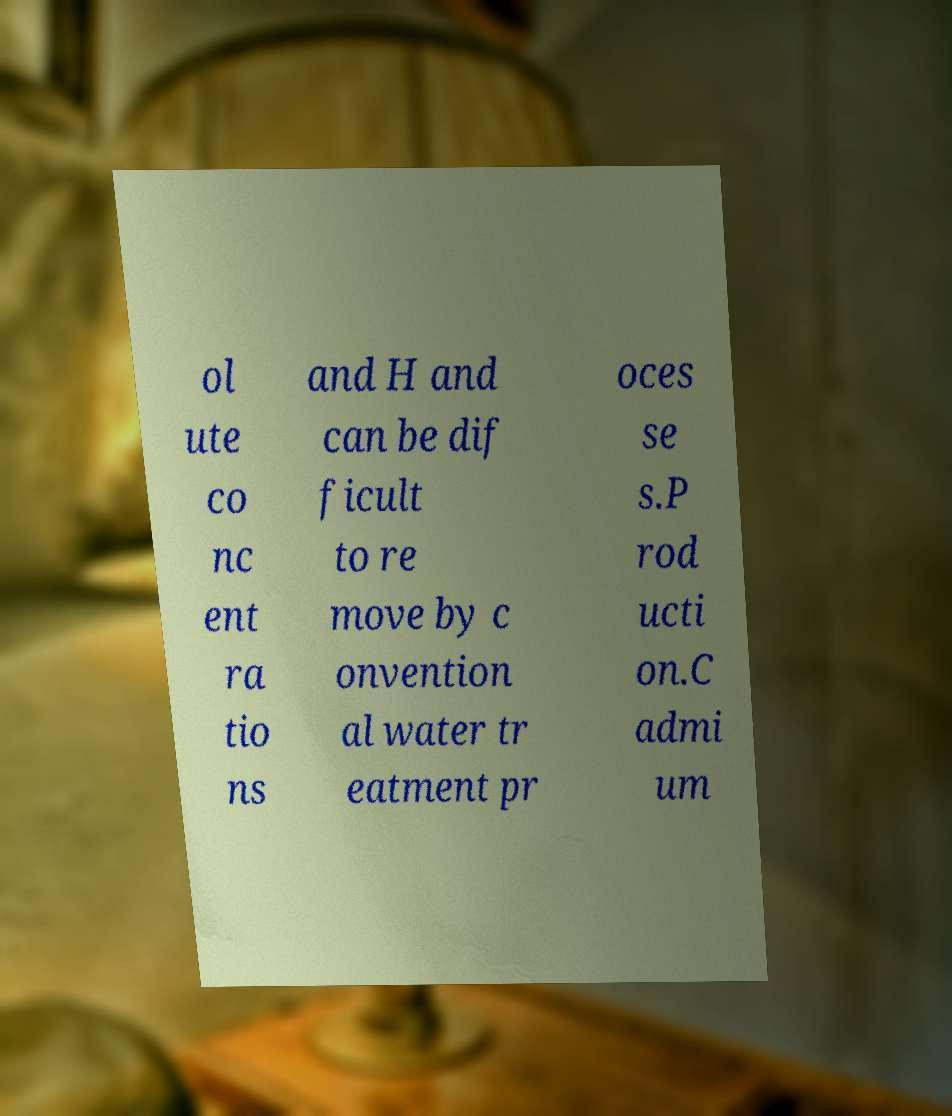Please identify and transcribe the text found in this image. ol ute co nc ent ra tio ns and H and can be dif ficult to re move by c onvention al water tr eatment pr oces se s.P rod ucti on.C admi um 